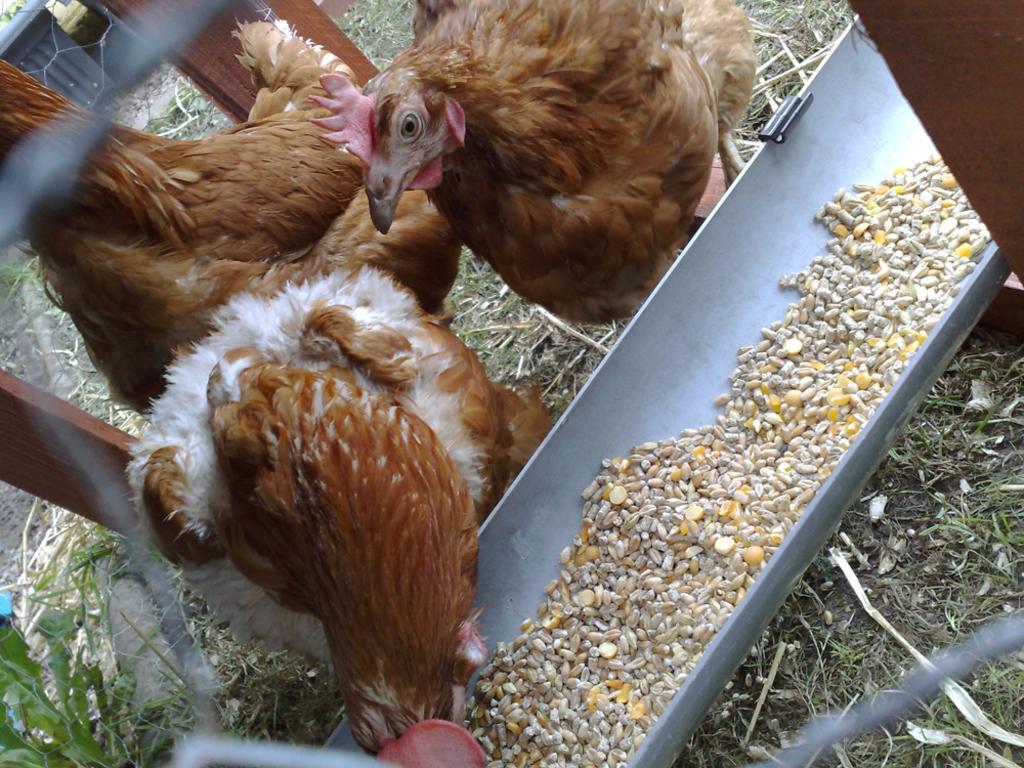Could you give a brief overview of what you see in this image? In this image we can see there are hens on the ground and there is a feeding tray, in that there are some food items. And there is a grass, plant and wooden sticks. 